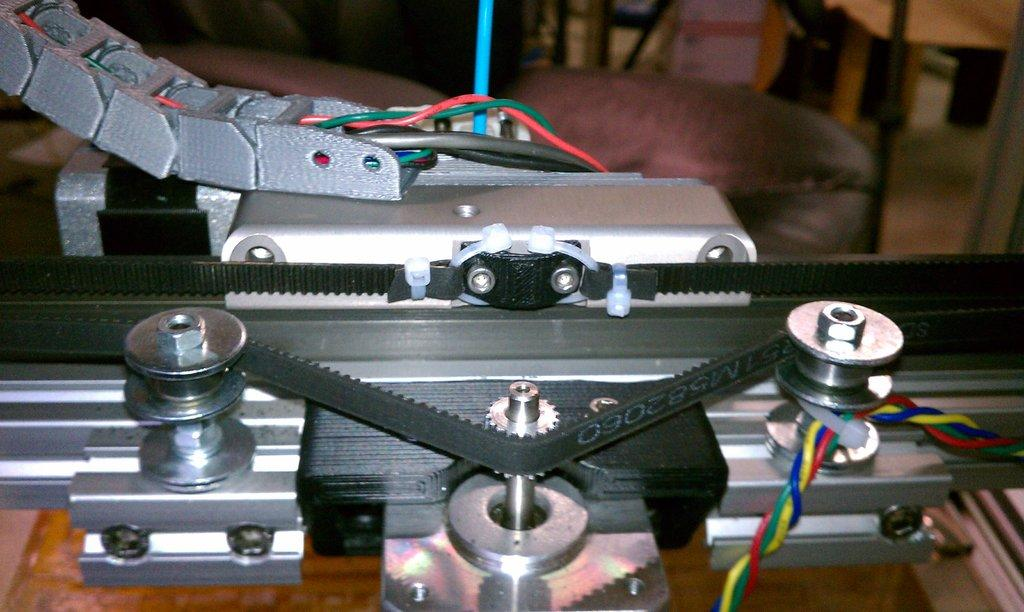What is the main object in the image? There is a machine in the image. What is located behind the machine? There are chairs behind the machine. Can you describe the object in the top right of the image? There is a wooden object in the top right of the image. What type of apparel is the machine wearing in the image? The machine is not wearing any apparel, as it is an inanimate object. What time of day is depicted in the image? The time of day cannot be determined from the image, as there are no clues to suggest morning or any other time. 